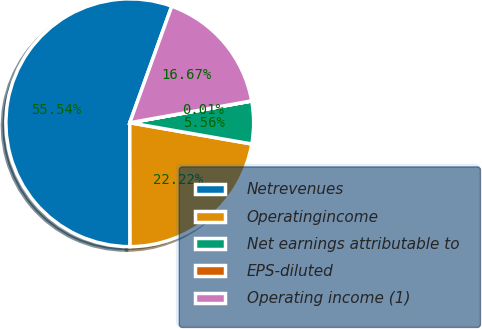<chart> <loc_0><loc_0><loc_500><loc_500><pie_chart><fcel>Netrevenues<fcel>Operatingincome<fcel>Net earnings attributable to<fcel>EPS-diluted<fcel>Operating income (1)<nl><fcel>55.54%<fcel>22.22%<fcel>5.56%<fcel>0.01%<fcel>16.67%<nl></chart> 